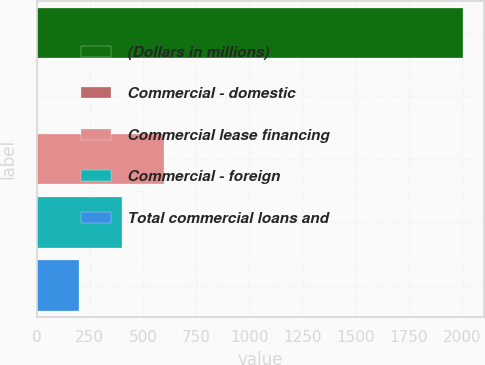Convert chart. <chart><loc_0><loc_0><loc_500><loc_500><bar_chart><fcel>(Dollars in millions)<fcel>Commercial - domestic<fcel>Commercial lease financing<fcel>Commercial - foreign<fcel>Total commercial loans and<nl><fcel>2005<fcel>0.13<fcel>601.6<fcel>401.11<fcel>200.62<nl></chart> 